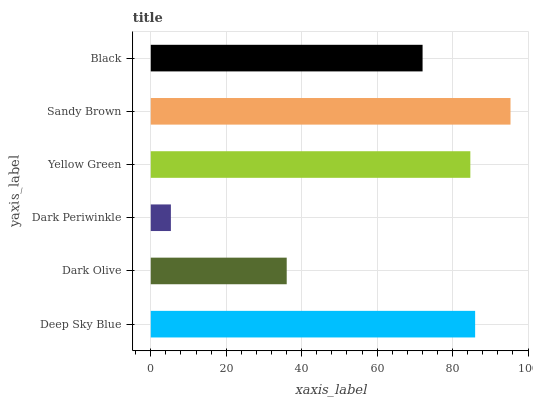Is Dark Periwinkle the minimum?
Answer yes or no. Yes. Is Sandy Brown the maximum?
Answer yes or no. Yes. Is Dark Olive the minimum?
Answer yes or no. No. Is Dark Olive the maximum?
Answer yes or no. No. Is Deep Sky Blue greater than Dark Olive?
Answer yes or no. Yes. Is Dark Olive less than Deep Sky Blue?
Answer yes or no. Yes. Is Dark Olive greater than Deep Sky Blue?
Answer yes or no. No. Is Deep Sky Blue less than Dark Olive?
Answer yes or no. No. Is Yellow Green the high median?
Answer yes or no. Yes. Is Black the low median?
Answer yes or no. Yes. Is Dark Olive the high median?
Answer yes or no. No. Is Dark Periwinkle the low median?
Answer yes or no. No. 